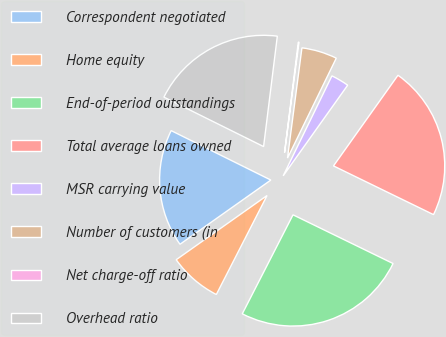Convert chart. <chart><loc_0><loc_0><loc_500><loc_500><pie_chart><fcel>Correspondent negotiated<fcel>Home equity<fcel>End-of-period outstandings<fcel>Total average loans owned<fcel>MSR carrying value<fcel>Number of customers (in<fcel>Net charge-off ratio<fcel>Overhead ratio<nl><fcel>17.12%<fcel>7.67%<fcel>25.32%<fcel>22.37%<fcel>2.62%<fcel>5.15%<fcel>0.1%<fcel>19.64%<nl></chart> 